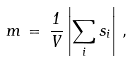<formula> <loc_0><loc_0><loc_500><loc_500>m \, = \, \frac { 1 } { V } \left | \sum _ { i } s _ { i } \right | \, ,</formula> 